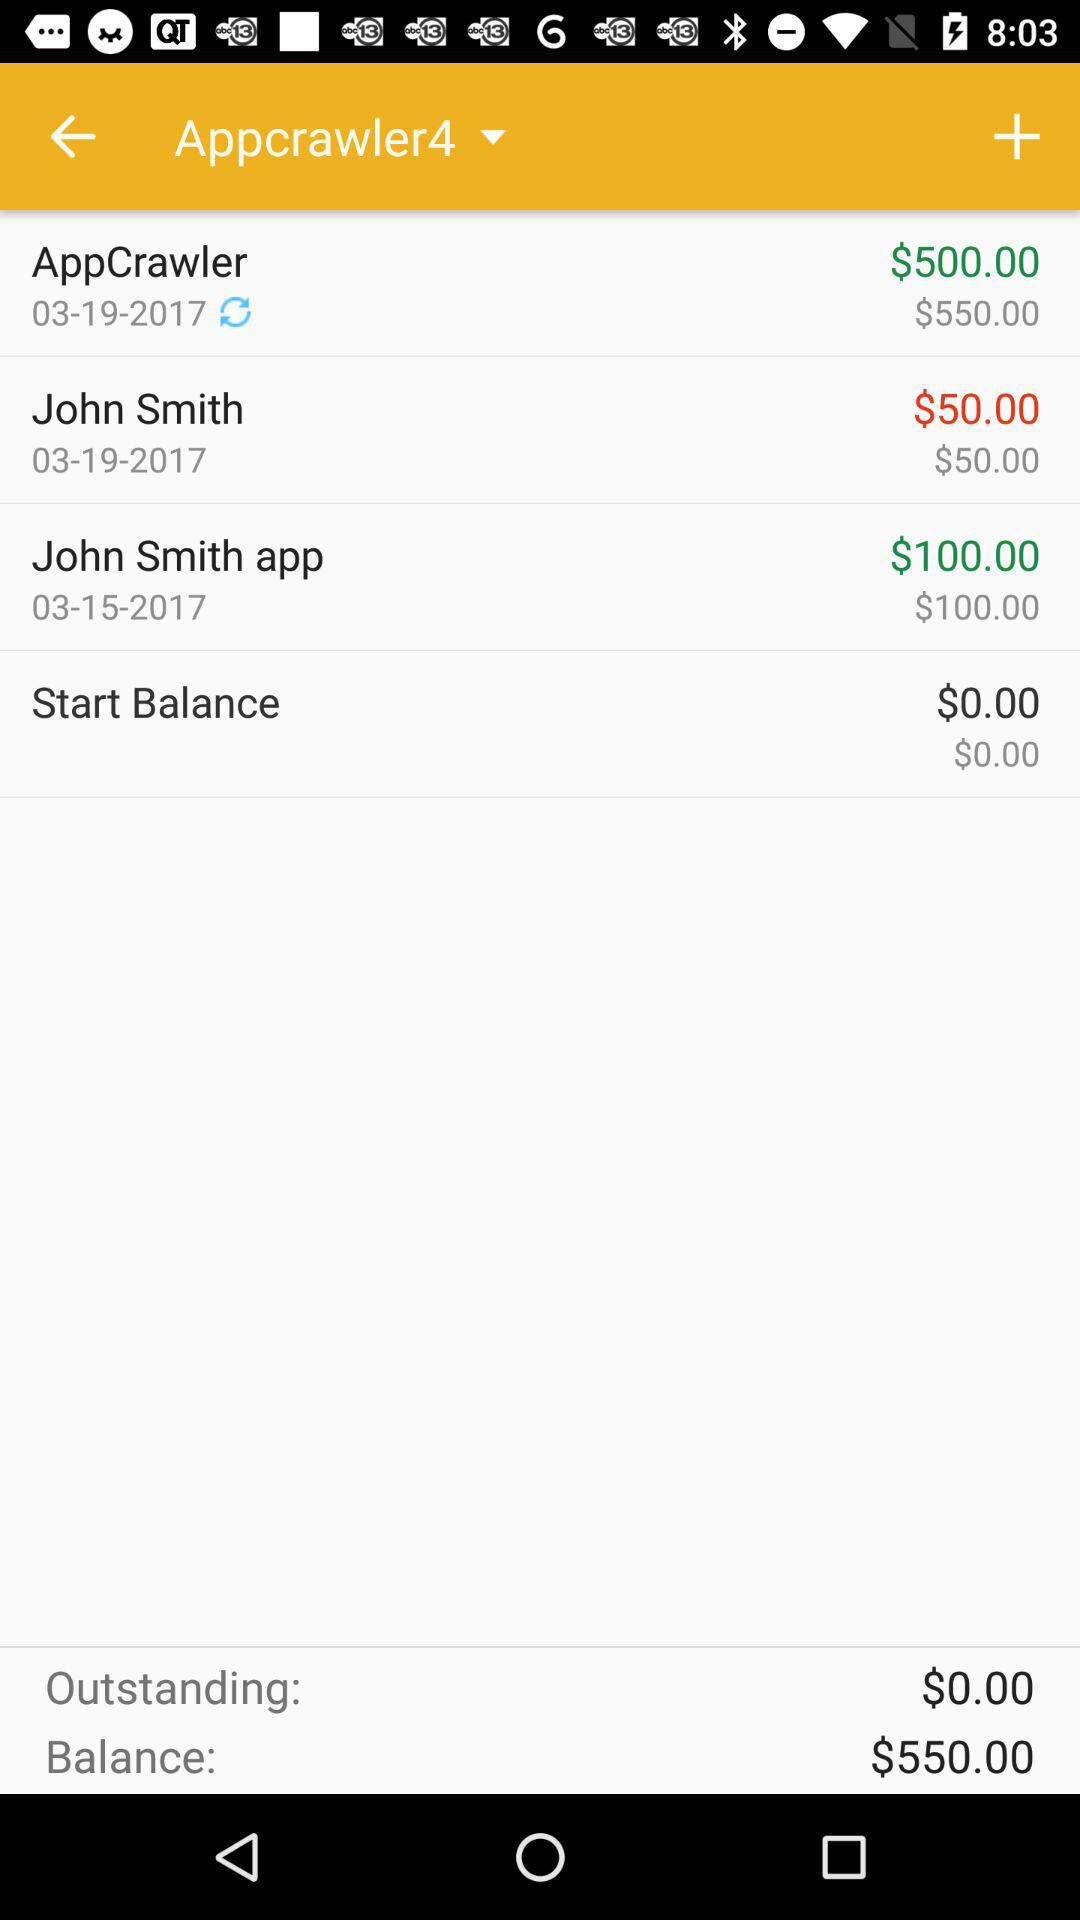How much is the balance of "AppCrawler" on 19th March 2017? The balance of "AppCrawler" is $500. 